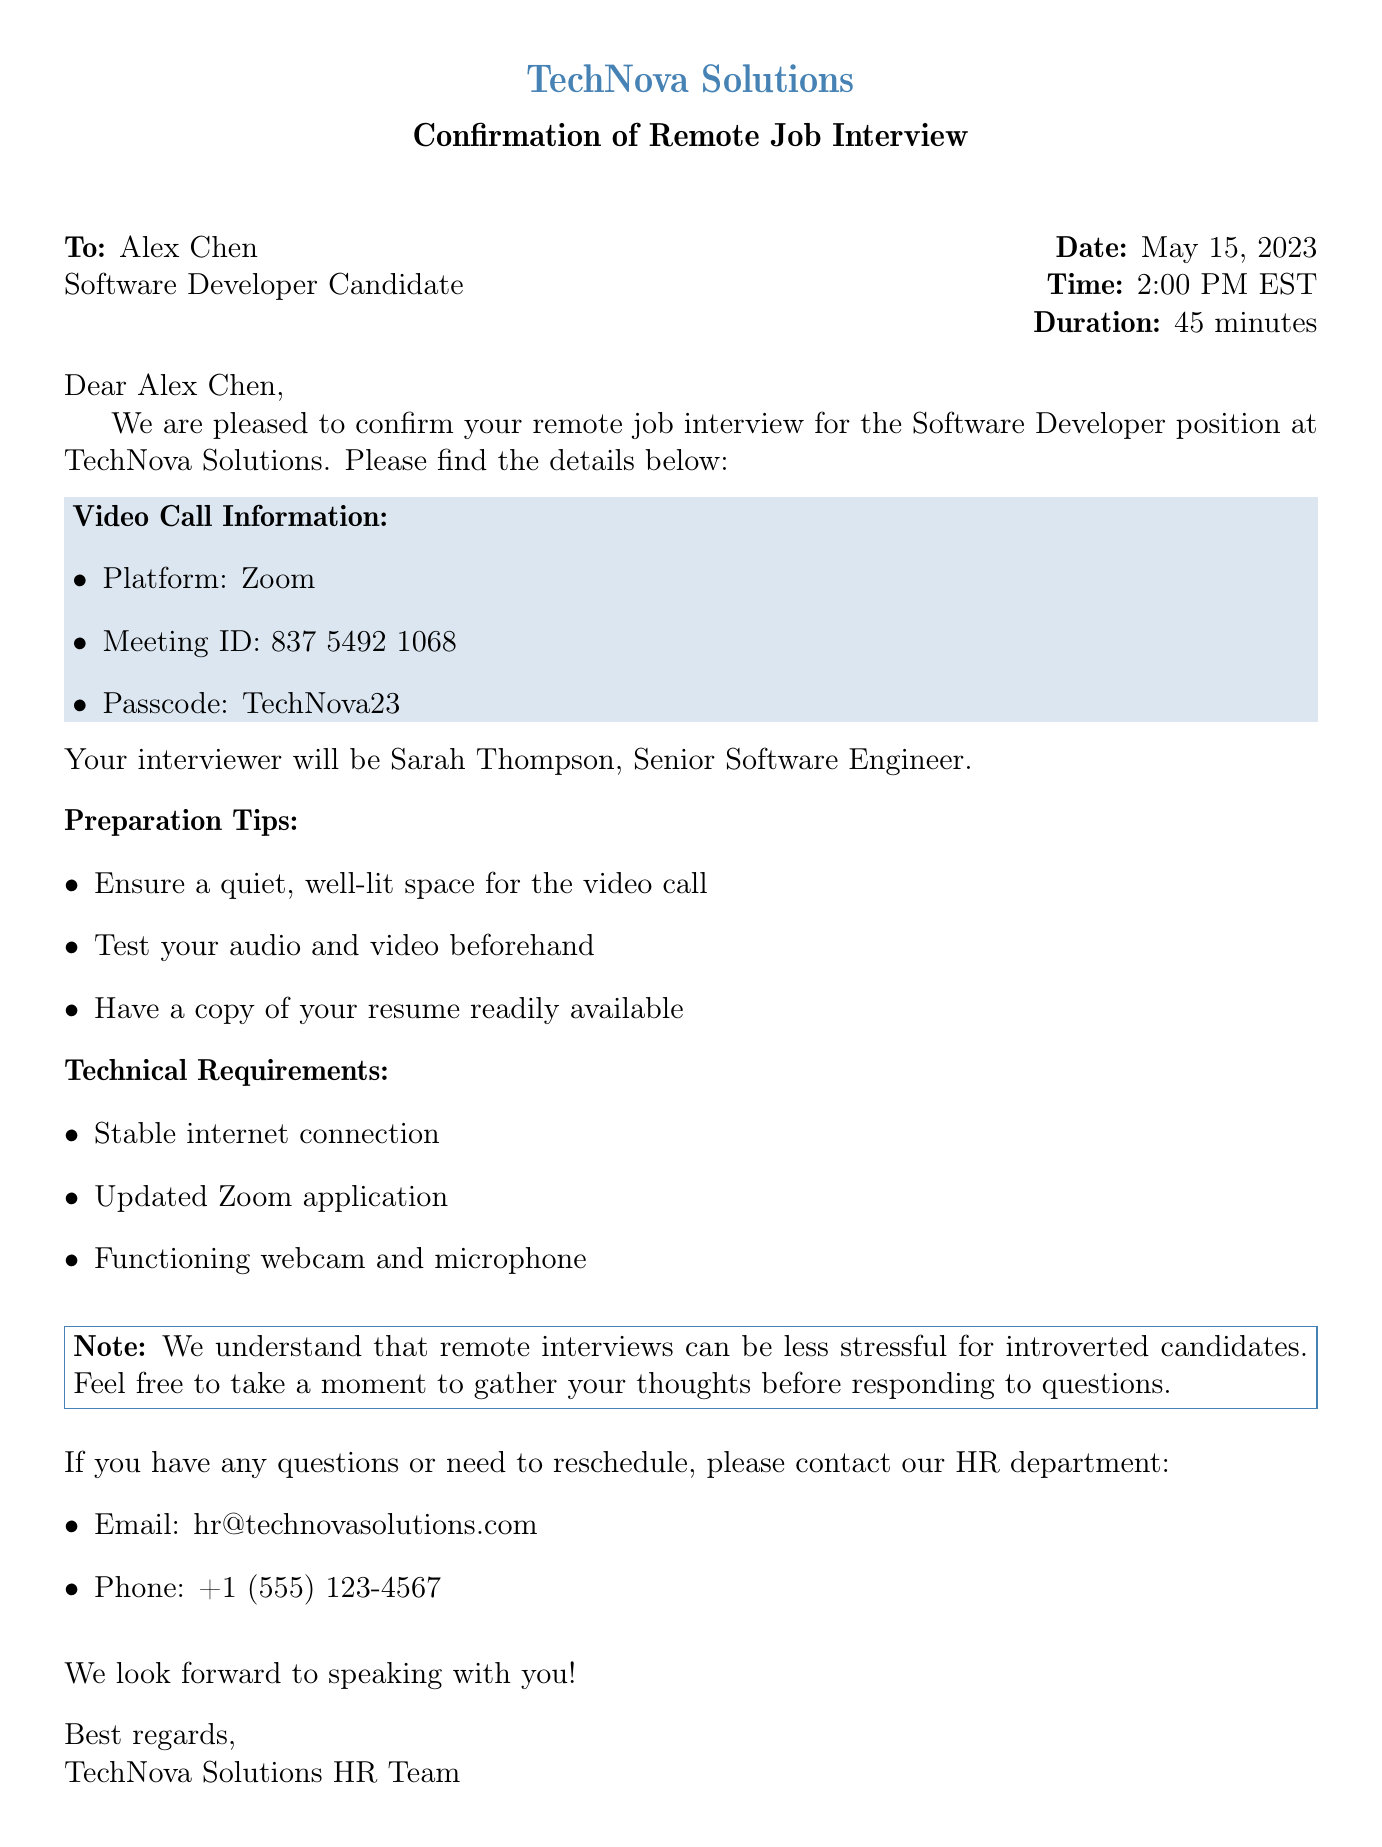what is the name of the candidate? The name of the candidate is specified at the beginning of the document as Alex Chen.
Answer: Alex Chen what position is the interview for? The position for the interview is clearly stated in the document as Software Developer.
Answer: Software Developer what is the date of the interview? The date for the interview is provided, which is May 15, 2023.
Answer: May 15, 2023 what platform will the video call be held on? The document specifies that the video call will take place on Zoom.
Answer: Zoom what is the passcode for the meeting? The passcode required for the meeting is mentioned as TechNova23.
Answer: TechNova23 who is the interviewer? The name of the interviewer is given as Sarah Thompson.
Answer: Sarah Thompson how long is the interview scheduled for? The duration of the interview is indicated as 45 minutes.
Answer: 45 minutes what should candidates prepare before the interview? The document lists several preparation tips; one key tip is to test your audio and video beforehand.
Answer: Test your audio and video beforehand what is the email address for HR contact? The HR contact email is provided in the document as hr@technovasolutions.com.
Answer: hr@technovasolutions.com what is mentioned about introverted candidates? The document notes that remote interviews can be less stressful for introverted candidates.
Answer: Less stressful for introverted candidates 